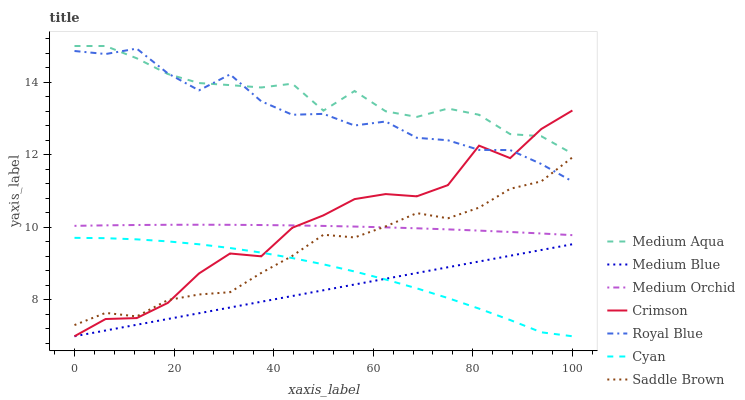Does Medium Blue have the minimum area under the curve?
Answer yes or no. Yes. Does Medium Aqua have the maximum area under the curve?
Answer yes or no. Yes. Does Royal Blue have the minimum area under the curve?
Answer yes or no. No. Does Royal Blue have the maximum area under the curve?
Answer yes or no. No. Is Medium Blue the smoothest?
Answer yes or no. Yes. Is Crimson the roughest?
Answer yes or no. Yes. Is Royal Blue the smoothest?
Answer yes or no. No. Is Royal Blue the roughest?
Answer yes or no. No. Does Medium Blue have the lowest value?
Answer yes or no. Yes. Does Royal Blue have the lowest value?
Answer yes or no. No. Does Medium Aqua have the highest value?
Answer yes or no. Yes. Does Royal Blue have the highest value?
Answer yes or no. No. Is Medium Blue less than Royal Blue?
Answer yes or no. Yes. Is Medium Aqua greater than Cyan?
Answer yes or no. Yes. Does Saddle Brown intersect Medium Orchid?
Answer yes or no. Yes. Is Saddle Brown less than Medium Orchid?
Answer yes or no. No. Is Saddle Brown greater than Medium Orchid?
Answer yes or no. No. Does Medium Blue intersect Royal Blue?
Answer yes or no. No. 